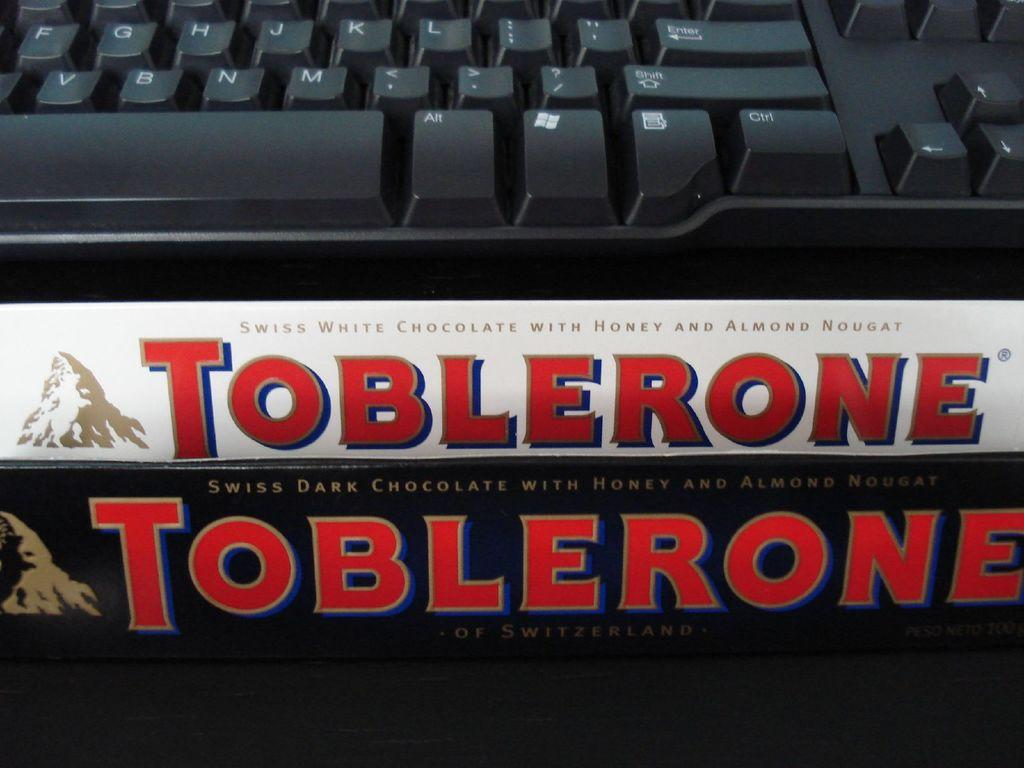<image>
Render a clear and concise summary of the photo. Two Toblerone bars sit in front of a computer keyboard. 